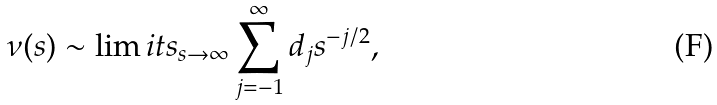<formula> <loc_0><loc_0><loc_500><loc_500>\nu ( s ) \sim \lim i t s _ { s \to \infty } \sum ^ { \infty } _ { j = - 1 } d _ { j } s ^ { - j / 2 } ,</formula> 